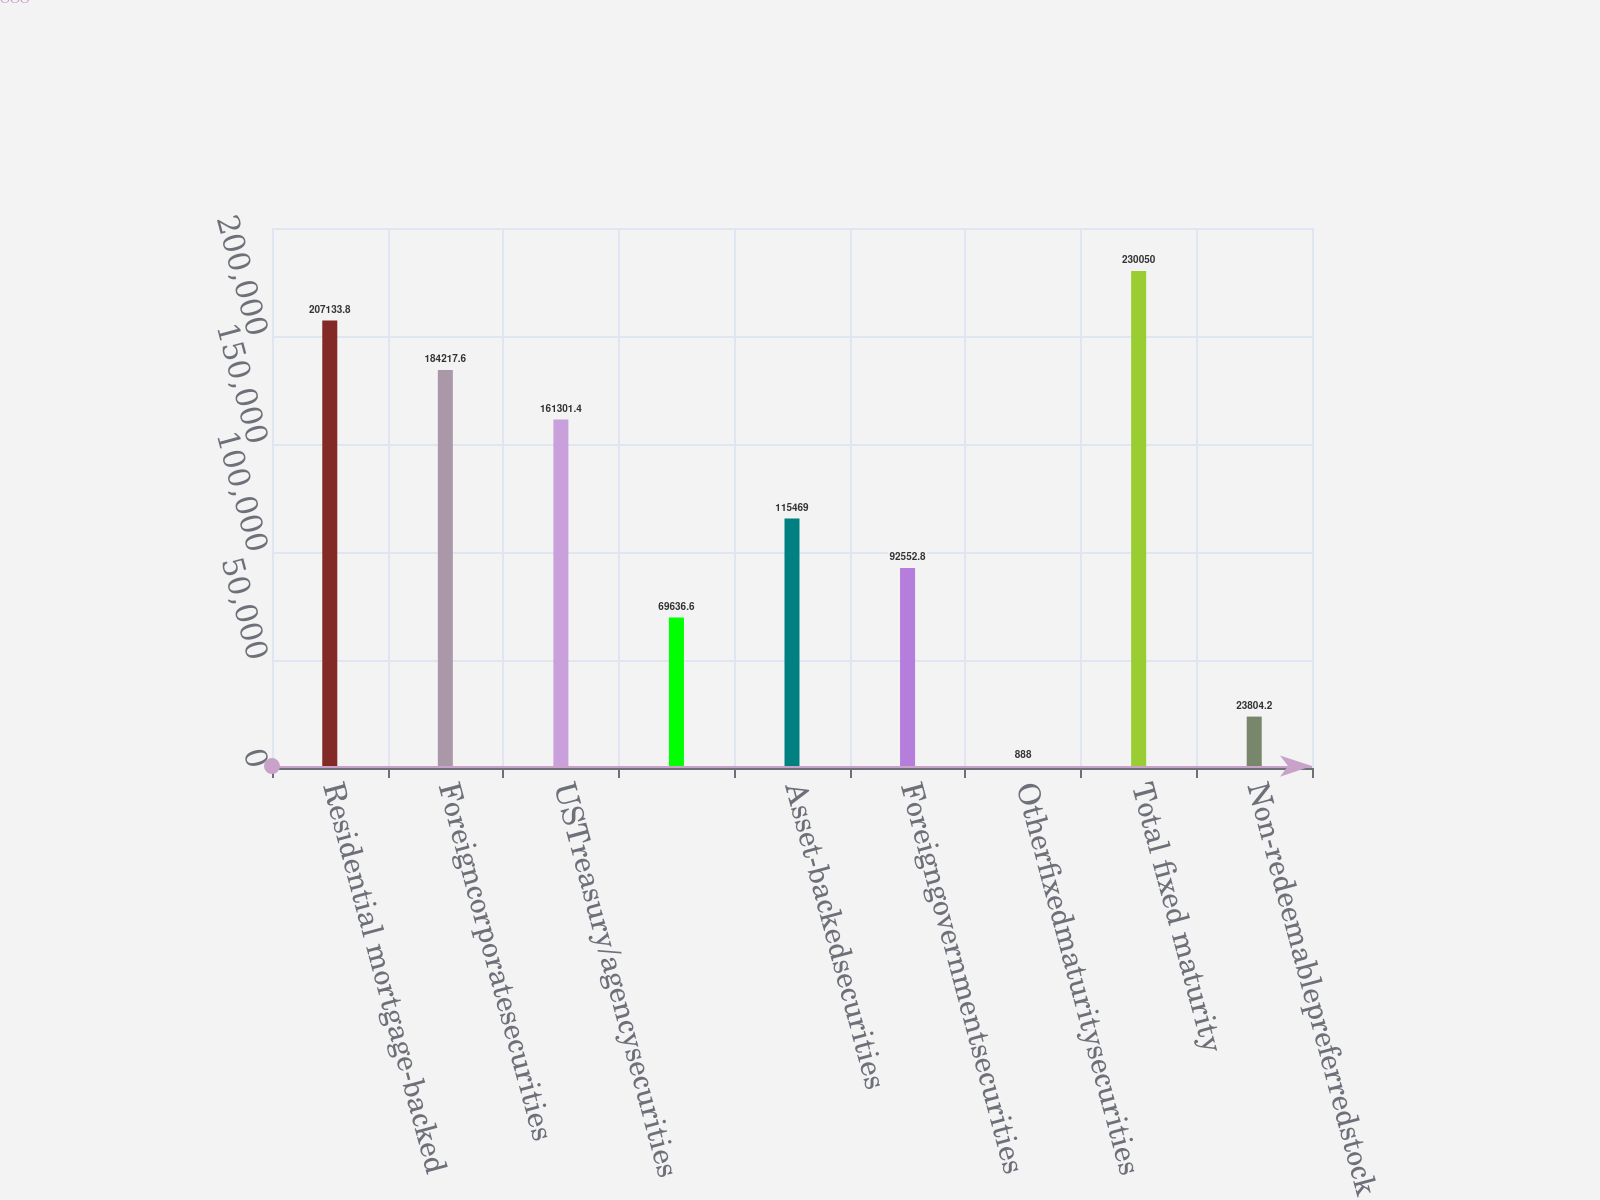Convert chart to OTSL. <chart><loc_0><loc_0><loc_500><loc_500><bar_chart><fcel>Residential mortgage-backed<fcel>Foreigncorporatesecurities<fcel>USTreasury/agencysecurities<fcel>Unnamed: 3<fcel>Asset-backedsecurities<fcel>Foreigngovernmentsecurities<fcel>Otherfixedmaturitysecurities<fcel>Total fixed maturity<fcel>Non-redeemablepreferredstock<nl><fcel>207134<fcel>184218<fcel>161301<fcel>69636.6<fcel>115469<fcel>92552.8<fcel>888<fcel>230050<fcel>23804.2<nl></chart> 